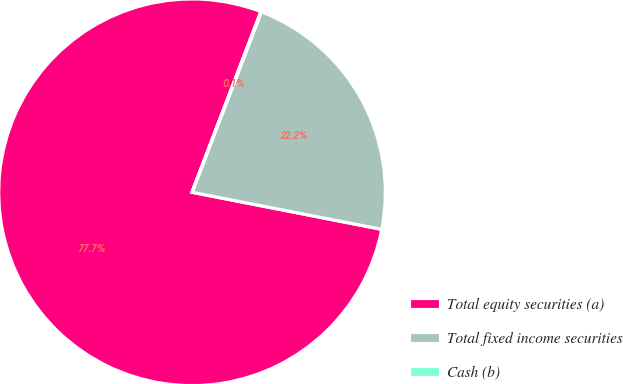Convert chart. <chart><loc_0><loc_0><loc_500><loc_500><pie_chart><fcel>Total equity securities (a)<fcel>Total fixed income securities<fcel>Cash (b)<nl><fcel>77.72%<fcel>22.23%<fcel>0.05%<nl></chart> 